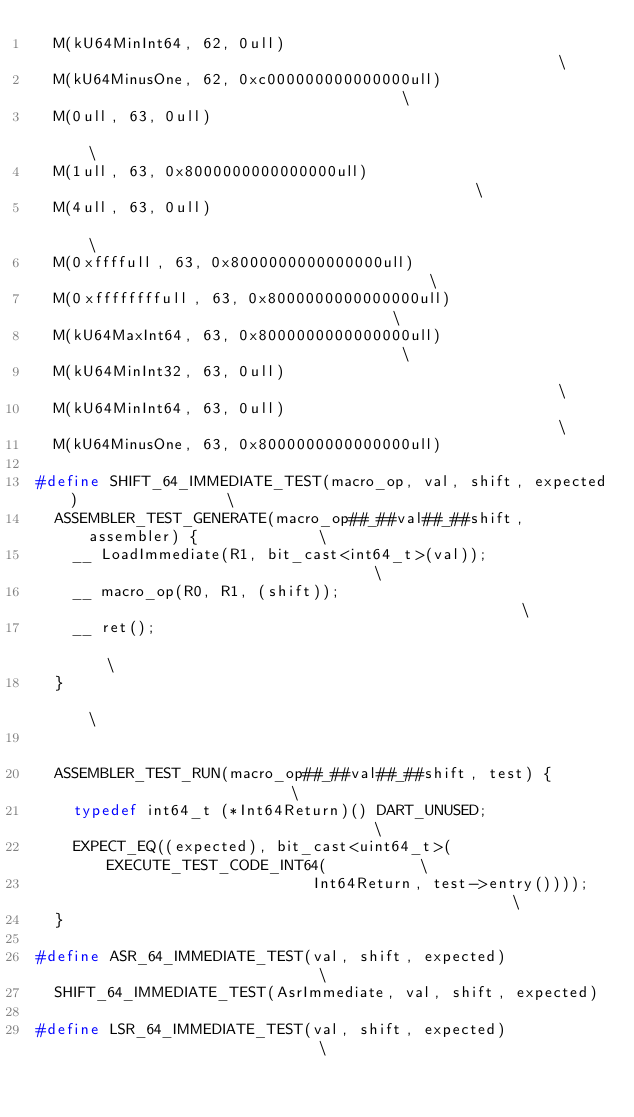Convert code to text. <code><loc_0><loc_0><loc_500><loc_500><_C++_>  M(kU64MinInt64, 62, 0ull)                                                    \
  M(kU64MinusOne, 62, 0xc000000000000000ull)                                   \
  M(0ull, 63, 0ull)                                                            \
  M(1ull, 63, 0x8000000000000000ull)                                           \
  M(4ull, 63, 0ull)                                                            \
  M(0xffffull, 63, 0x8000000000000000ull)                                      \
  M(0xffffffffull, 63, 0x8000000000000000ull)                                  \
  M(kU64MaxInt64, 63, 0x8000000000000000ull)                                   \
  M(kU64MinInt32, 63, 0ull)                                                    \
  M(kU64MinInt64, 63, 0ull)                                                    \
  M(kU64MinusOne, 63, 0x8000000000000000ull)

#define SHIFT_64_IMMEDIATE_TEST(macro_op, val, shift, expected)                \
  ASSEMBLER_TEST_GENERATE(macro_op##_##val##_##shift, assembler) {             \
    __ LoadImmediate(R1, bit_cast<int64_t>(val));                              \
    __ macro_op(R0, R1, (shift));                                              \
    __ ret();                                                                  \
  }                                                                            \
                                                                               \
  ASSEMBLER_TEST_RUN(macro_op##_##val##_##shift, test) {                       \
    typedef int64_t (*Int64Return)() DART_UNUSED;                              \
    EXPECT_EQ((expected), bit_cast<uint64_t>(EXECUTE_TEST_CODE_INT64(          \
                              Int64Return, test->entry())));                   \
  }

#define ASR_64_IMMEDIATE_TEST(val, shift, expected)                            \
  SHIFT_64_IMMEDIATE_TEST(AsrImmediate, val, shift, expected)

#define LSR_64_IMMEDIATE_TEST(val, shift, expected)                            \</code> 